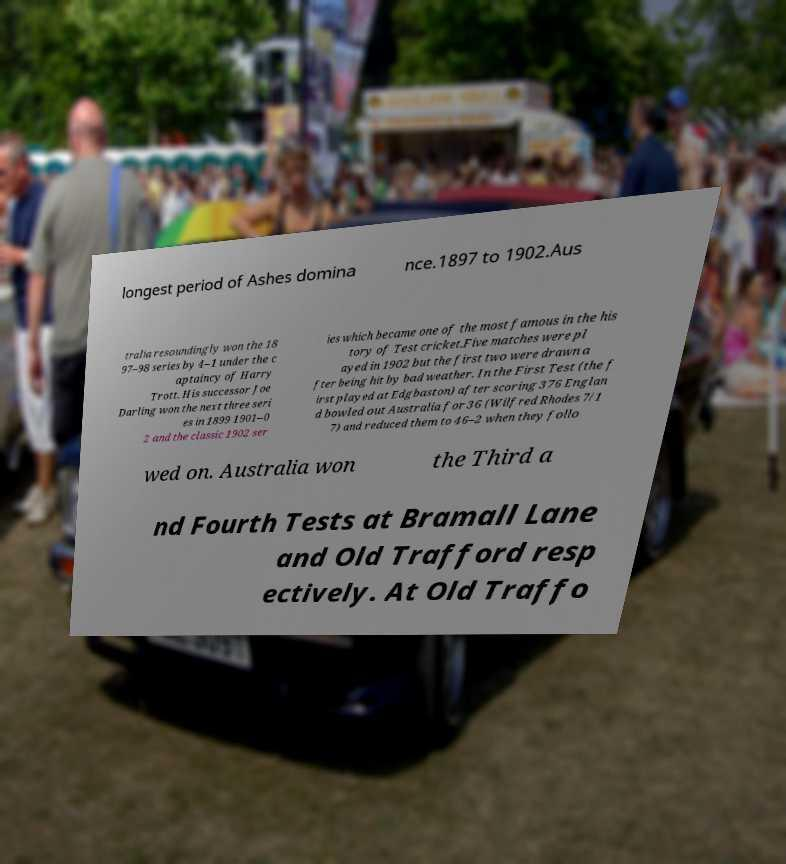Could you assist in decoding the text presented in this image and type it out clearly? longest period of Ashes domina nce.1897 to 1902.Aus tralia resoundingly won the 18 97–98 series by 4–1 under the c aptaincy of Harry Trott. His successor Joe Darling won the next three seri es in 1899 1901–0 2 and the classic 1902 ser ies which became one of the most famous in the his tory of Test cricket.Five matches were pl ayed in 1902 but the first two were drawn a fter being hit by bad weather. In the First Test (the f irst played at Edgbaston) after scoring 376 Englan d bowled out Australia for 36 (Wilfred Rhodes 7/1 7) and reduced them to 46–2 when they follo wed on. Australia won the Third a nd Fourth Tests at Bramall Lane and Old Trafford resp ectively. At Old Traffo 